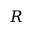Convert formula to latex. <formula><loc_0><loc_0><loc_500><loc_500>R</formula> 